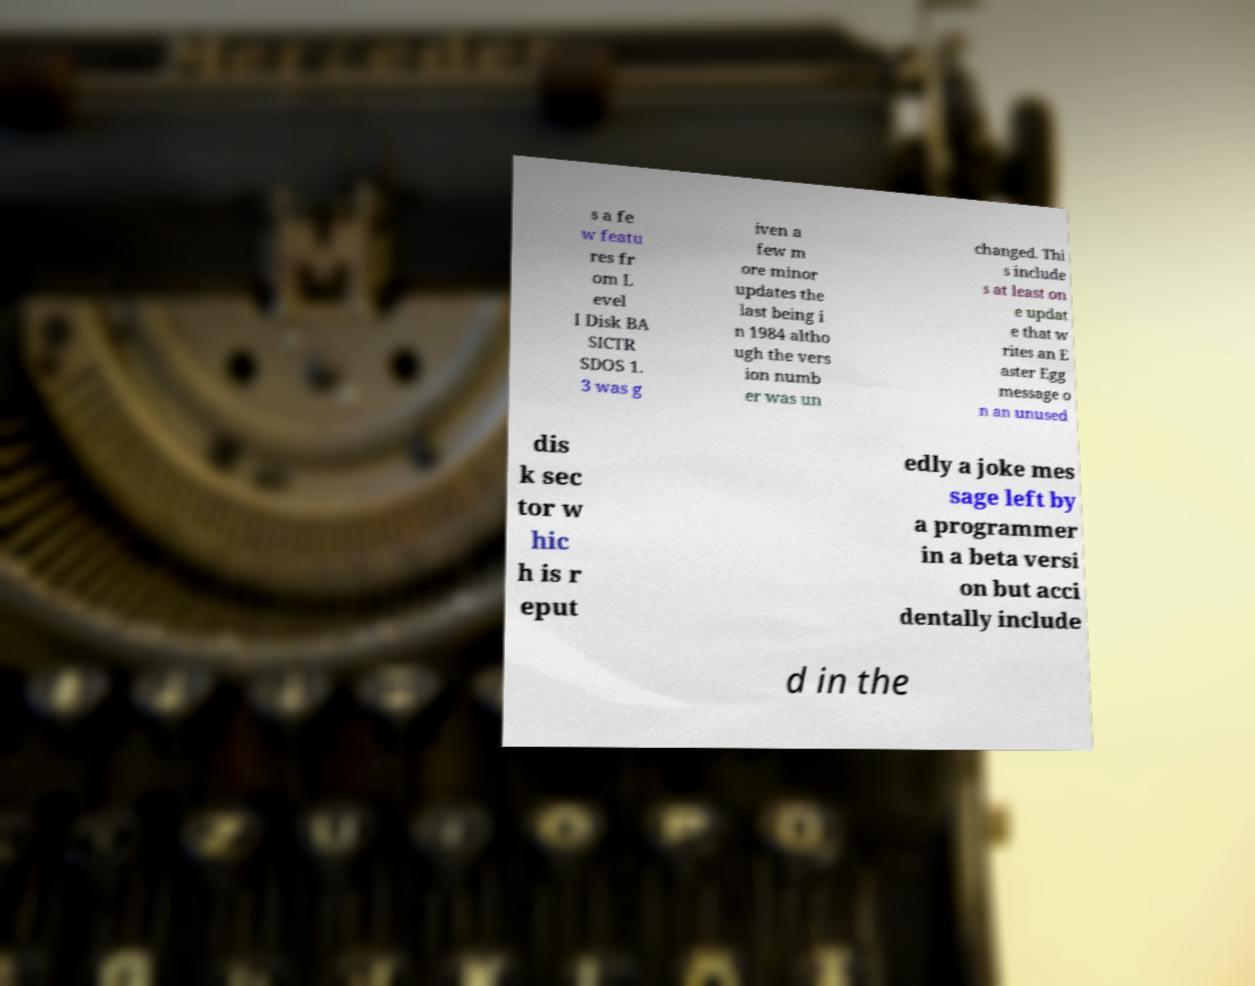For documentation purposes, I need the text within this image transcribed. Could you provide that? s a fe w featu res fr om L evel I Disk BA SICTR SDOS 1. 3 was g iven a few m ore minor updates the last being i n 1984 altho ugh the vers ion numb er was un changed. Thi s include s at least on e updat e that w rites an E aster Egg message o n an unused dis k sec tor w hic h is r eput edly a joke mes sage left by a programmer in a beta versi on but acci dentally include d in the 